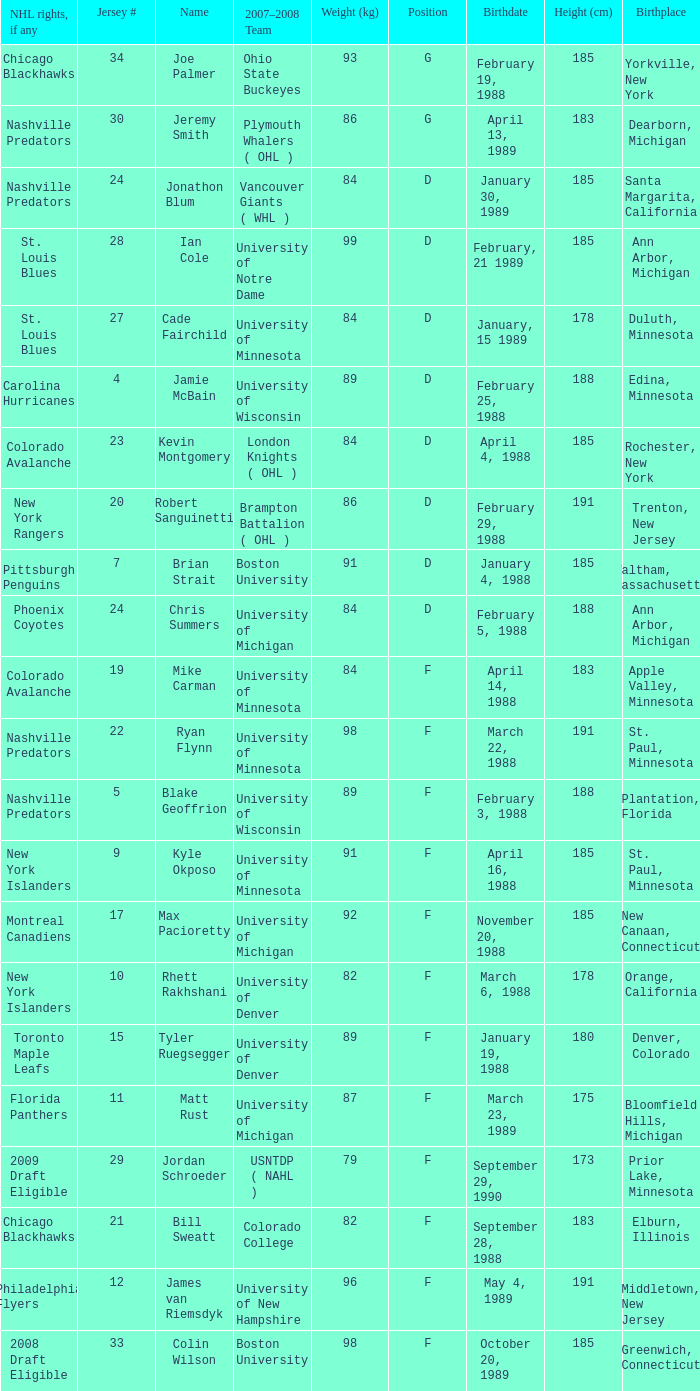What height in centimeters is associated with a birthplace of bloomfield hills, michigan? 175.0. 